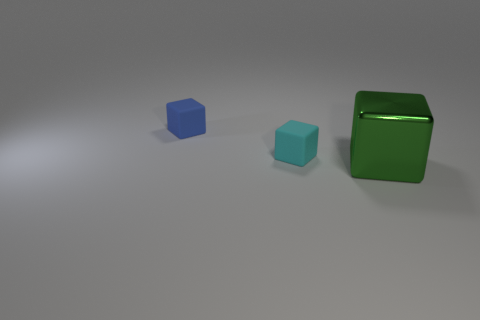What number of green things are either big things or small matte cubes?
Offer a very short reply. 1. Is the blue thing the same shape as the large green metallic thing?
Keep it short and to the point. Yes. There is a thing that is in front of the tiny cyan cube; is there a small matte object on the left side of it?
Provide a succinct answer. Yes. Is the number of tiny cyan blocks that are on the left side of the tiny cyan block the same as the number of tiny gray spheres?
Offer a terse response. Yes. What number of other objects are there of the same size as the green shiny thing?
Offer a terse response. 0. Is the tiny cube behind the tiny cyan rubber object made of the same material as the tiny cube in front of the tiny blue object?
Ensure brevity in your answer.  Yes. What is the size of the matte object in front of the cube left of the tiny cyan thing?
Keep it short and to the point. Small. There is a large block; what number of tiny blocks are behind it?
Your answer should be very brief. 2. How many things are made of the same material as the tiny blue cube?
Give a very brief answer. 1. Is the small cube behind the cyan rubber thing made of the same material as the small cyan object?
Provide a short and direct response. Yes. 